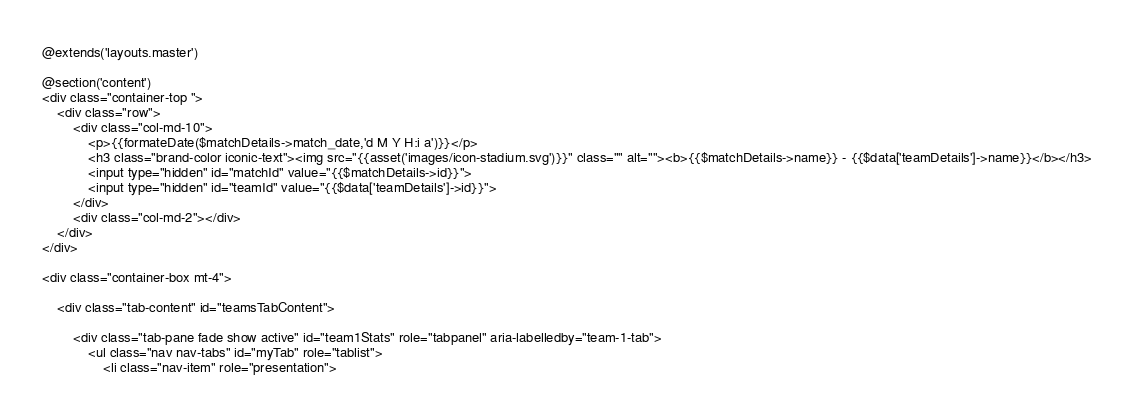<code> <loc_0><loc_0><loc_500><loc_500><_PHP_>@extends('layouts.master')

@section('content')
<div class="container-top ">
    <div class="row">
        <div class="col-md-10">
            <p>{{formateDate($matchDetails->match_date,'d M Y H:i a')}}</p>
            <h3 class="brand-color iconic-text"><img src="{{asset('images/icon-stadium.svg')}}" class="" alt=""><b>{{$matchDetails->name}} - {{$data['teamDetails']->name}}</b></h3>
            <input type="hidden" id="matchId" value="{{$matchDetails->id}}">
            <input type="hidden" id="teamId" value="{{$data['teamDetails']->id}}">
        </div>
        <div class="col-md-2"></div>
    </div>
</div>

<div class="container-box mt-4">

    <div class="tab-content" id="teamsTabContent">

        <div class="tab-pane fade show active" id="team1Stats" role="tabpanel" aria-labelledby="team-1-tab">
            <ul class="nav nav-tabs" id="myTab" role="tablist">
                <li class="nav-item" role="presentation"></code> 